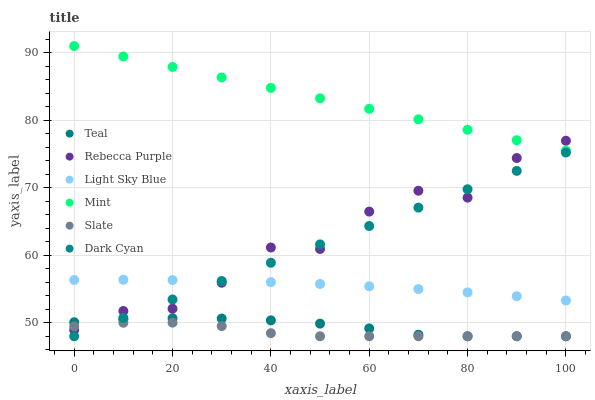Does Slate have the minimum area under the curve?
Answer yes or no. Yes. Does Mint have the maximum area under the curve?
Answer yes or no. Yes. Does Light Sky Blue have the minimum area under the curve?
Answer yes or no. No. Does Light Sky Blue have the maximum area under the curve?
Answer yes or no. No. Is Dark Cyan the smoothest?
Answer yes or no. Yes. Is Rebecca Purple the roughest?
Answer yes or no. Yes. Is Light Sky Blue the smoothest?
Answer yes or no. No. Is Light Sky Blue the roughest?
Answer yes or no. No. Does Slate have the lowest value?
Answer yes or no. Yes. Does Light Sky Blue have the lowest value?
Answer yes or no. No. Does Mint have the highest value?
Answer yes or no. Yes. Does Light Sky Blue have the highest value?
Answer yes or no. No. Is Dark Cyan less than Mint?
Answer yes or no. Yes. Is Light Sky Blue greater than Teal?
Answer yes or no. Yes. Does Teal intersect Slate?
Answer yes or no. Yes. Is Teal less than Slate?
Answer yes or no. No. Is Teal greater than Slate?
Answer yes or no. No. Does Dark Cyan intersect Mint?
Answer yes or no. No. 